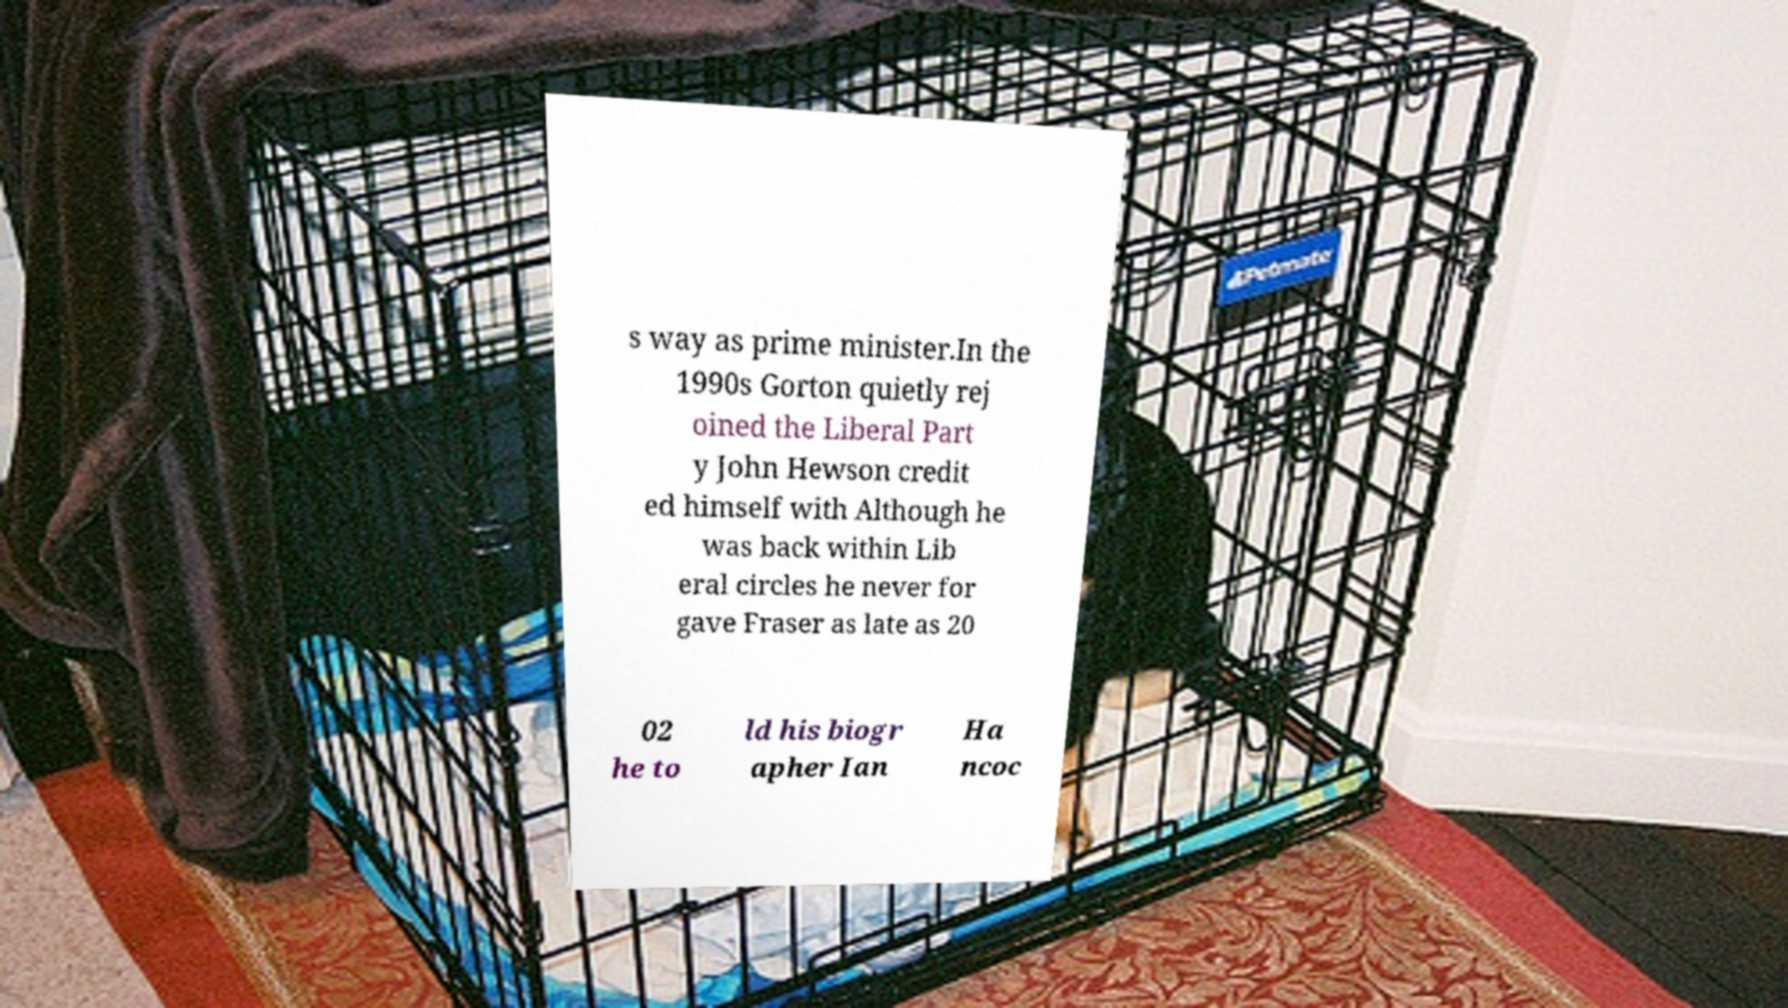I need the written content from this picture converted into text. Can you do that? s way as prime minister.In the 1990s Gorton quietly rej oined the Liberal Part y John Hewson credit ed himself with Although he was back within Lib eral circles he never for gave Fraser as late as 20 02 he to ld his biogr apher Ian Ha ncoc 